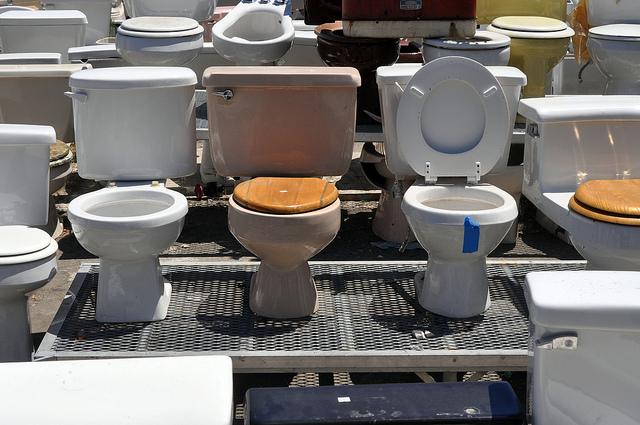What are on display?
Keep it brief. Toilets. Are any seat covers made of wood?
Answer briefly. Yes. What color is the commode part of the toilet in the middle with the wooden seat cover?
Write a very short answer. Beige. 